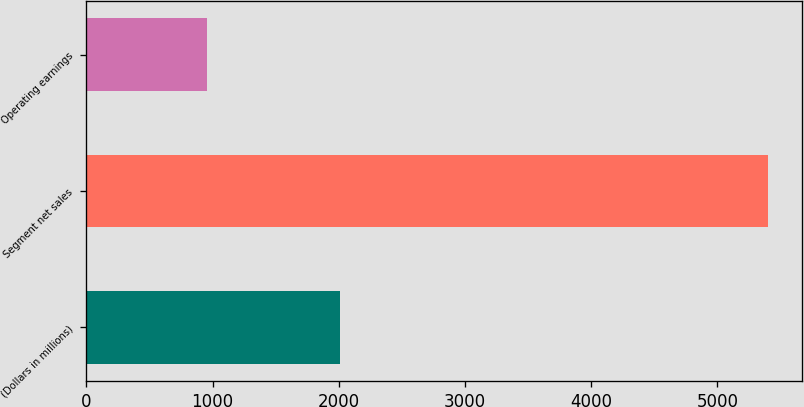Convert chart to OTSL. <chart><loc_0><loc_0><loc_500><loc_500><bar_chart><fcel>(Dollars in millions)<fcel>Segment net sales<fcel>Operating earnings<nl><fcel>2006<fcel>5400<fcel>958<nl></chart> 